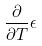<formula> <loc_0><loc_0><loc_500><loc_500>\frac { \partial } { \partial T } \epsilon</formula> 